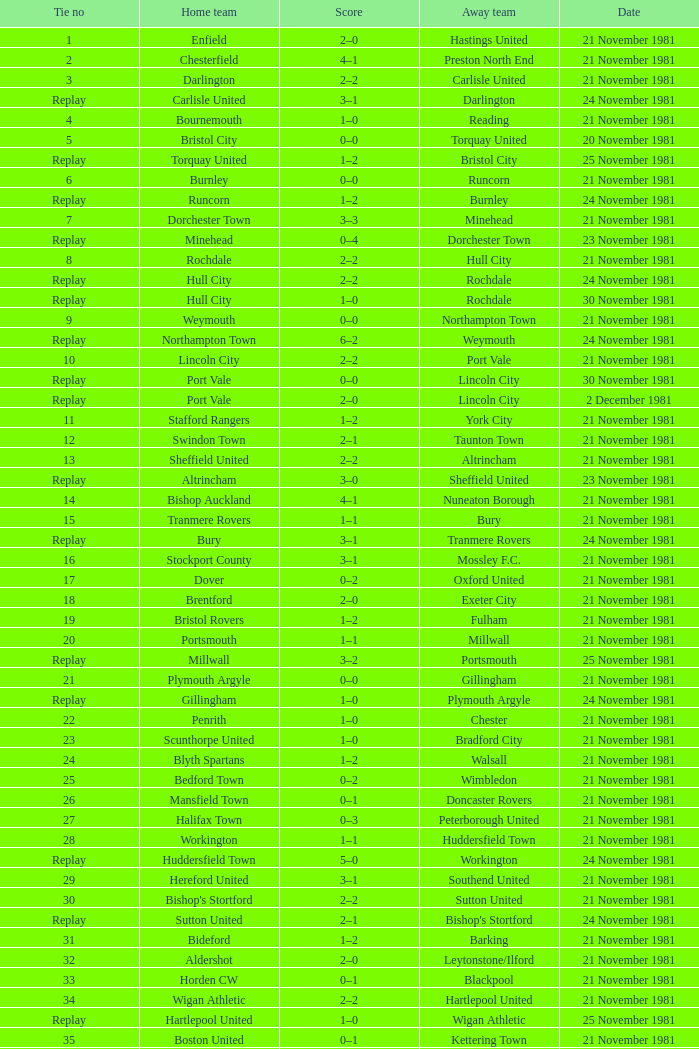What is enfield's tie number? 1.0. 